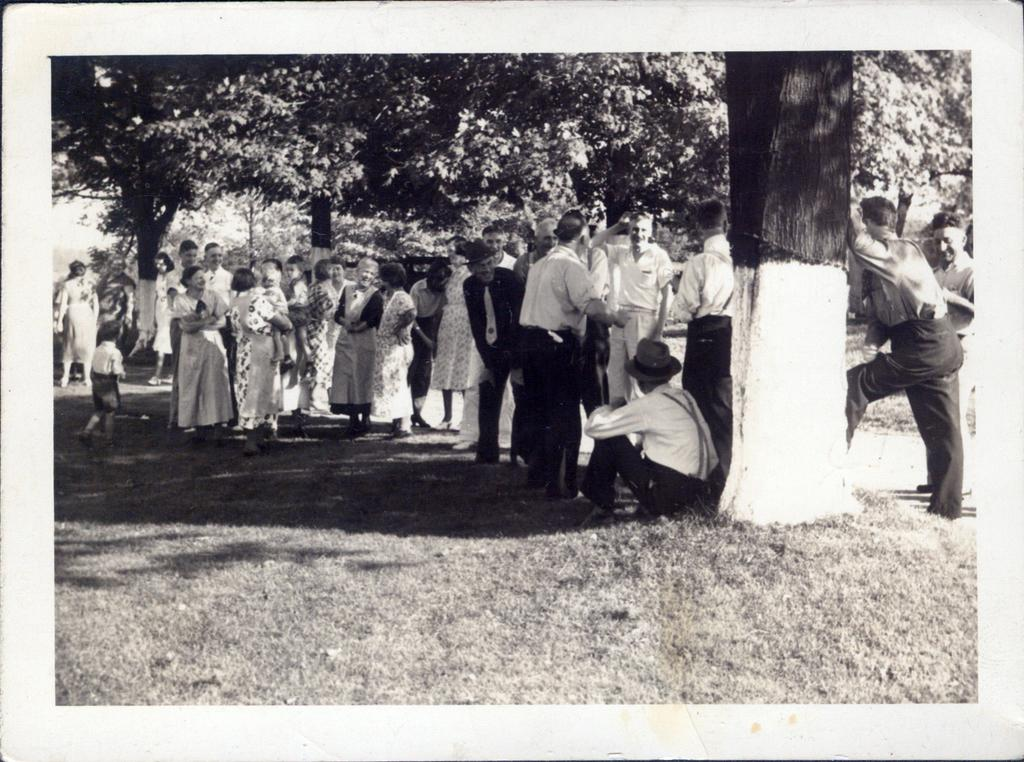What type of vegetation is at the bottom of the image? There is grass at the bottom of the image. What are the people in the image doing? The people in the image are standing and sitting. What can be seen behind the people in the image? There are trees visible behind the people. How many geese are flying over the trees in the image? There are no geese visible in the image; only trees are mentioned behind the people. What type of sugar is being used by the people in the image? There is no mention of sugar or any food items in the image; it only features people standing and sitting with trees in the background. 